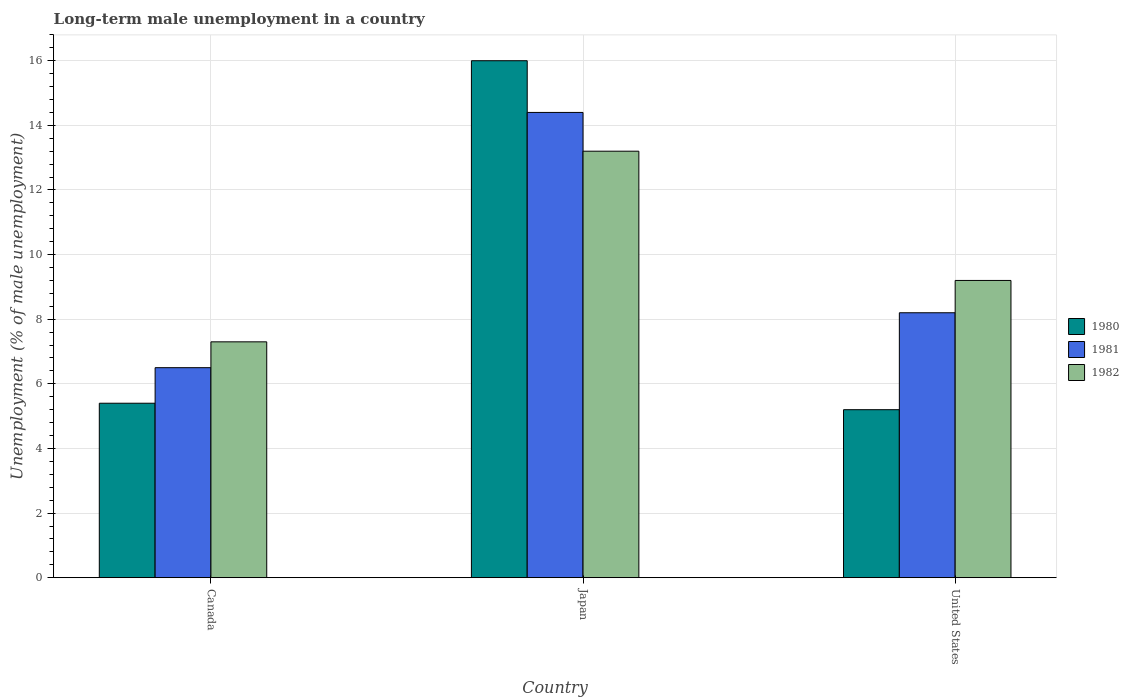Are the number of bars on each tick of the X-axis equal?
Provide a short and direct response. Yes. How many bars are there on the 2nd tick from the right?
Offer a very short reply. 3. What is the percentage of long-term unemployed male population in 1982 in United States?
Give a very brief answer. 9.2. Across all countries, what is the maximum percentage of long-term unemployed male population in 1982?
Your answer should be very brief. 13.2. Across all countries, what is the minimum percentage of long-term unemployed male population in 1980?
Make the answer very short. 5.2. In which country was the percentage of long-term unemployed male population in 1981 maximum?
Offer a terse response. Japan. What is the total percentage of long-term unemployed male population in 1981 in the graph?
Your response must be concise. 29.1. What is the difference between the percentage of long-term unemployed male population in 1981 in Canada and that in Japan?
Provide a short and direct response. -7.9. What is the difference between the percentage of long-term unemployed male population in 1981 in Japan and the percentage of long-term unemployed male population in 1982 in United States?
Ensure brevity in your answer.  5.2. What is the average percentage of long-term unemployed male population in 1982 per country?
Ensure brevity in your answer.  9.9. What is the difference between the percentage of long-term unemployed male population of/in 1981 and percentage of long-term unemployed male population of/in 1982 in Japan?
Make the answer very short. 1.2. In how many countries, is the percentage of long-term unemployed male population in 1982 greater than 14.8 %?
Your answer should be very brief. 0. What is the ratio of the percentage of long-term unemployed male population in 1982 in Canada to that in Japan?
Offer a very short reply. 0.55. Is the difference between the percentage of long-term unemployed male population in 1981 in Japan and United States greater than the difference between the percentage of long-term unemployed male population in 1982 in Japan and United States?
Offer a terse response. Yes. What is the difference between the highest and the second highest percentage of long-term unemployed male population in 1981?
Keep it short and to the point. -6.2. What is the difference between the highest and the lowest percentage of long-term unemployed male population in 1981?
Offer a terse response. 7.9. What does the 1st bar from the left in United States represents?
Provide a short and direct response. 1980. How many countries are there in the graph?
Provide a short and direct response. 3. Does the graph contain any zero values?
Provide a short and direct response. No. Where does the legend appear in the graph?
Your answer should be compact. Center right. What is the title of the graph?
Offer a terse response. Long-term male unemployment in a country. Does "1974" appear as one of the legend labels in the graph?
Your answer should be very brief. No. What is the label or title of the Y-axis?
Your response must be concise. Unemployment (% of male unemployment). What is the Unemployment (% of male unemployment) in 1980 in Canada?
Your answer should be compact. 5.4. What is the Unemployment (% of male unemployment) of 1981 in Canada?
Offer a very short reply. 6.5. What is the Unemployment (% of male unemployment) of 1982 in Canada?
Provide a succinct answer. 7.3. What is the Unemployment (% of male unemployment) of 1981 in Japan?
Offer a very short reply. 14.4. What is the Unemployment (% of male unemployment) of 1982 in Japan?
Keep it short and to the point. 13.2. What is the Unemployment (% of male unemployment) of 1980 in United States?
Your answer should be very brief. 5.2. What is the Unemployment (% of male unemployment) of 1981 in United States?
Provide a short and direct response. 8.2. What is the Unemployment (% of male unemployment) of 1982 in United States?
Offer a terse response. 9.2. Across all countries, what is the maximum Unemployment (% of male unemployment) of 1980?
Give a very brief answer. 16. Across all countries, what is the maximum Unemployment (% of male unemployment) of 1981?
Ensure brevity in your answer.  14.4. Across all countries, what is the maximum Unemployment (% of male unemployment) in 1982?
Make the answer very short. 13.2. Across all countries, what is the minimum Unemployment (% of male unemployment) of 1980?
Provide a short and direct response. 5.2. Across all countries, what is the minimum Unemployment (% of male unemployment) of 1982?
Your response must be concise. 7.3. What is the total Unemployment (% of male unemployment) of 1980 in the graph?
Provide a short and direct response. 26.6. What is the total Unemployment (% of male unemployment) in 1981 in the graph?
Provide a succinct answer. 29.1. What is the total Unemployment (% of male unemployment) of 1982 in the graph?
Ensure brevity in your answer.  29.7. What is the difference between the Unemployment (% of male unemployment) in 1981 in Canada and that in United States?
Ensure brevity in your answer.  -1.7. What is the difference between the Unemployment (% of male unemployment) in 1982 in Canada and that in United States?
Give a very brief answer. -1.9. What is the difference between the Unemployment (% of male unemployment) of 1980 in Japan and that in United States?
Offer a very short reply. 10.8. What is the difference between the Unemployment (% of male unemployment) of 1981 in Japan and that in United States?
Your answer should be compact. 6.2. What is the difference between the Unemployment (% of male unemployment) of 1982 in Japan and that in United States?
Your answer should be very brief. 4. What is the difference between the Unemployment (% of male unemployment) of 1980 in Canada and the Unemployment (% of male unemployment) of 1982 in Japan?
Your answer should be compact. -7.8. What is the difference between the Unemployment (% of male unemployment) of 1981 in Canada and the Unemployment (% of male unemployment) of 1982 in Japan?
Your response must be concise. -6.7. What is the difference between the Unemployment (% of male unemployment) in 1980 in Canada and the Unemployment (% of male unemployment) in 1981 in United States?
Your response must be concise. -2.8. What is the difference between the Unemployment (% of male unemployment) of 1980 in Canada and the Unemployment (% of male unemployment) of 1982 in United States?
Your answer should be compact. -3.8. What is the difference between the Unemployment (% of male unemployment) of 1980 in Japan and the Unemployment (% of male unemployment) of 1981 in United States?
Offer a terse response. 7.8. What is the difference between the Unemployment (% of male unemployment) of 1980 in Japan and the Unemployment (% of male unemployment) of 1982 in United States?
Offer a very short reply. 6.8. What is the difference between the Unemployment (% of male unemployment) in 1981 in Japan and the Unemployment (% of male unemployment) in 1982 in United States?
Your answer should be very brief. 5.2. What is the average Unemployment (% of male unemployment) in 1980 per country?
Your answer should be compact. 8.87. What is the average Unemployment (% of male unemployment) of 1981 per country?
Your answer should be very brief. 9.7. What is the average Unemployment (% of male unemployment) of 1982 per country?
Your answer should be compact. 9.9. What is the difference between the Unemployment (% of male unemployment) of 1980 and Unemployment (% of male unemployment) of 1981 in Canada?
Your response must be concise. -1.1. What is the difference between the Unemployment (% of male unemployment) in 1980 and Unemployment (% of male unemployment) in 1981 in Japan?
Ensure brevity in your answer.  1.6. What is the difference between the Unemployment (% of male unemployment) of 1980 and Unemployment (% of male unemployment) of 1982 in United States?
Provide a short and direct response. -4. What is the difference between the Unemployment (% of male unemployment) of 1981 and Unemployment (% of male unemployment) of 1982 in United States?
Keep it short and to the point. -1. What is the ratio of the Unemployment (% of male unemployment) in 1980 in Canada to that in Japan?
Make the answer very short. 0.34. What is the ratio of the Unemployment (% of male unemployment) in 1981 in Canada to that in Japan?
Provide a short and direct response. 0.45. What is the ratio of the Unemployment (% of male unemployment) in 1982 in Canada to that in Japan?
Give a very brief answer. 0.55. What is the ratio of the Unemployment (% of male unemployment) of 1981 in Canada to that in United States?
Offer a very short reply. 0.79. What is the ratio of the Unemployment (% of male unemployment) of 1982 in Canada to that in United States?
Make the answer very short. 0.79. What is the ratio of the Unemployment (% of male unemployment) in 1980 in Japan to that in United States?
Offer a terse response. 3.08. What is the ratio of the Unemployment (% of male unemployment) of 1981 in Japan to that in United States?
Your response must be concise. 1.76. What is the ratio of the Unemployment (% of male unemployment) in 1982 in Japan to that in United States?
Keep it short and to the point. 1.43. What is the difference between the highest and the second highest Unemployment (% of male unemployment) of 1980?
Offer a very short reply. 10.6. What is the difference between the highest and the lowest Unemployment (% of male unemployment) of 1981?
Offer a very short reply. 7.9. What is the difference between the highest and the lowest Unemployment (% of male unemployment) in 1982?
Provide a short and direct response. 5.9. 